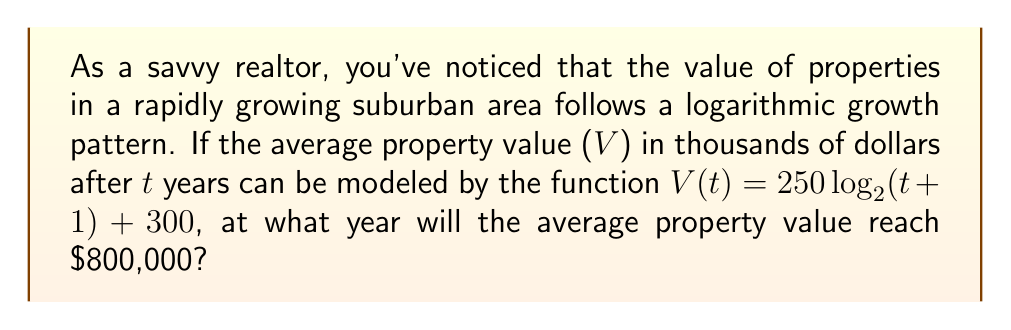Can you answer this question? Let's approach this step-by-step:

1) We need to solve the equation:
   $V(t) = 800$

2) Substituting the given function:
   $250 \log_2(t+1) + 300 = 800$

3) Subtract 300 from both sides:
   $250 \log_2(t+1) = 500$

4) Divide both sides by 250:
   $\log_2(t+1) = 2$

5) To solve for t, we need to apply the inverse function (exponential) to both sides:
   $2^{\log_2(t+1)} = 2^2$

6) Simplify the left side:
   $t + 1 = 4$

7) Subtract 1 from both sides:
   $t = 3$

Therefore, the average property value will reach $800,000 after 3 years.
Answer: 3 years 